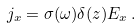Convert formula to latex. <formula><loc_0><loc_0><loc_500><loc_500>j _ { x } = \sigma ( \omega ) \delta ( z ) E _ { x } \, .</formula> 